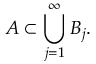<formula> <loc_0><loc_0><loc_500><loc_500>A \subset \bigcup _ { j = 1 } ^ { \infty } B _ { j } .</formula> 